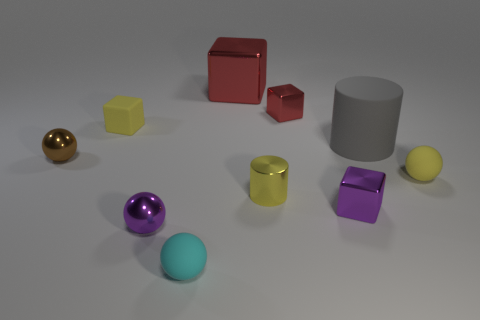Subtract 1 cubes. How many cubes are left? 3 Subtract all balls. How many objects are left? 6 Subtract all large green metallic objects. Subtract all purple metal spheres. How many objects are left? 9 Add 7 yellow matte objects. How many yellow matte objects are left? 9 Add 4 tiny cyan balls. How many tiny cyan balls exist? 5 Subtract 0 green cylinders. How many objects are left? 10 